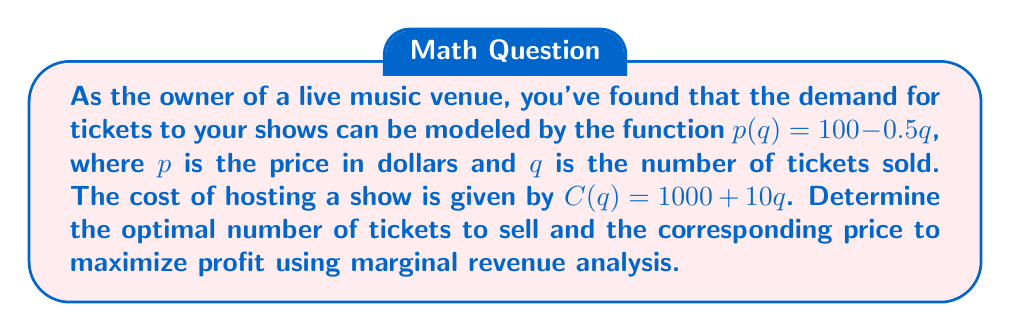Give your solution to this math problem. 1) First, let's find the revenue function $R(q)$:
   $R(q) = p(q) \cdot q = (100 - 0.5q) \cdot q = 100q - 0.5q^2$

2) The marginal revenue function is the derivative of the revenue function:
   $MR(q) = \frac{dR}{dq} = 100 - q$

3) The marginal cost function is the derivative of the cost function:
   $MC(q) = \frac{dC}{dq} = 10$

4) To maximize profit, set $MR = MC$:
   $100 - q = 10$
   $-q = -90$
   $q = 90$

5) This gives us the optimal number of tickets to sell. To find the price, substitute $q = 90$ into the demand function:
   $p(90) = 100 - 0.5(90) = 55$

6) To verify this maximizes profit, we can calculate the second derivative of the profit function:
   $\Pi(q) = R(q) - C(q) = (100q - 0.5q^2) - (1000 + 10q) = 90q - 0.5q^2 - 1000$
   $\frac{d\Pi}{dq} = 90 - q$
   $\frac{d^2\Pi}{dq^2} = -1 < 0$, confirming a maximum.
Answer: Sell 90 tickets at $55 each. 